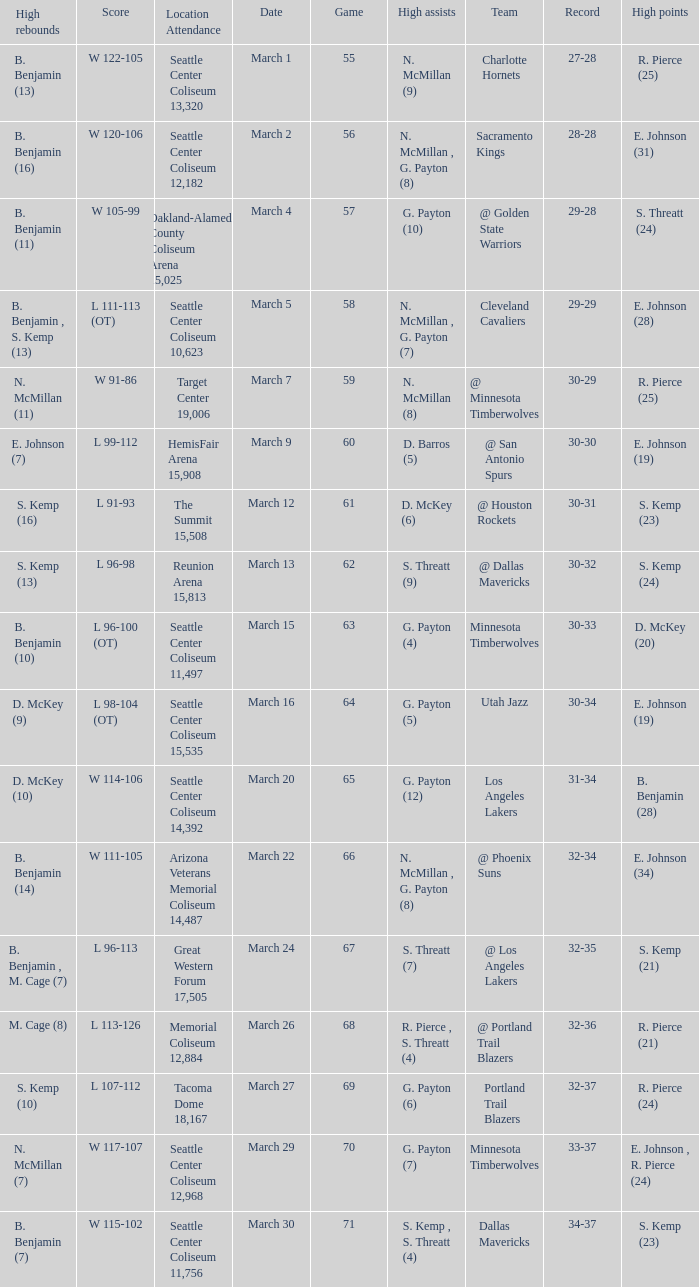WhichScore has a Location Attendance of seattle center coliseum 11,497? L 96-100 (OT). 